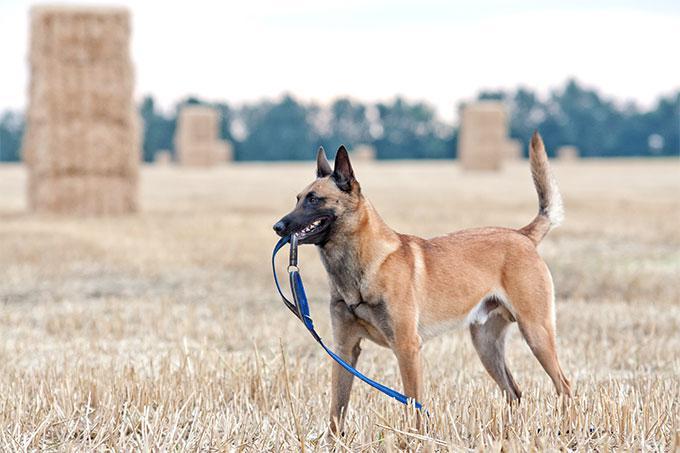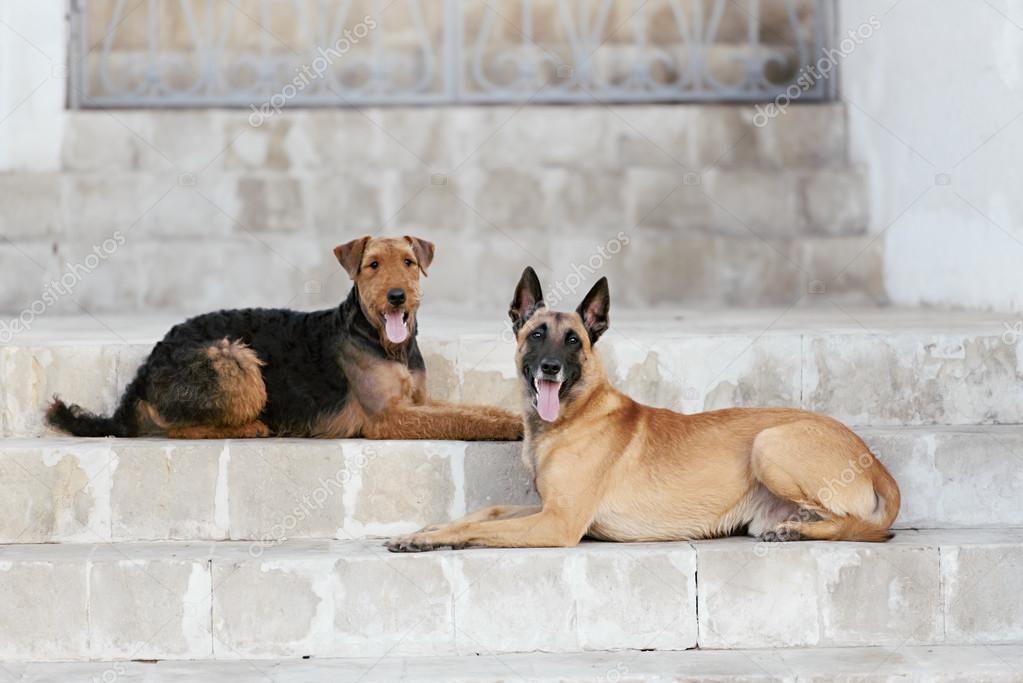The first image is the image on the left, the second image is the image on the right. Examine the images to the left and right. Is the description "An image shows one standing german shepherd facing leftward." accurate? Answer yes or no. Yes. The first image is the image on the left, the second image is the image on the right. For the images shown, is this caption "One of the images contains a dog touching a blue collar." true? Answer yes or no. Yes. 